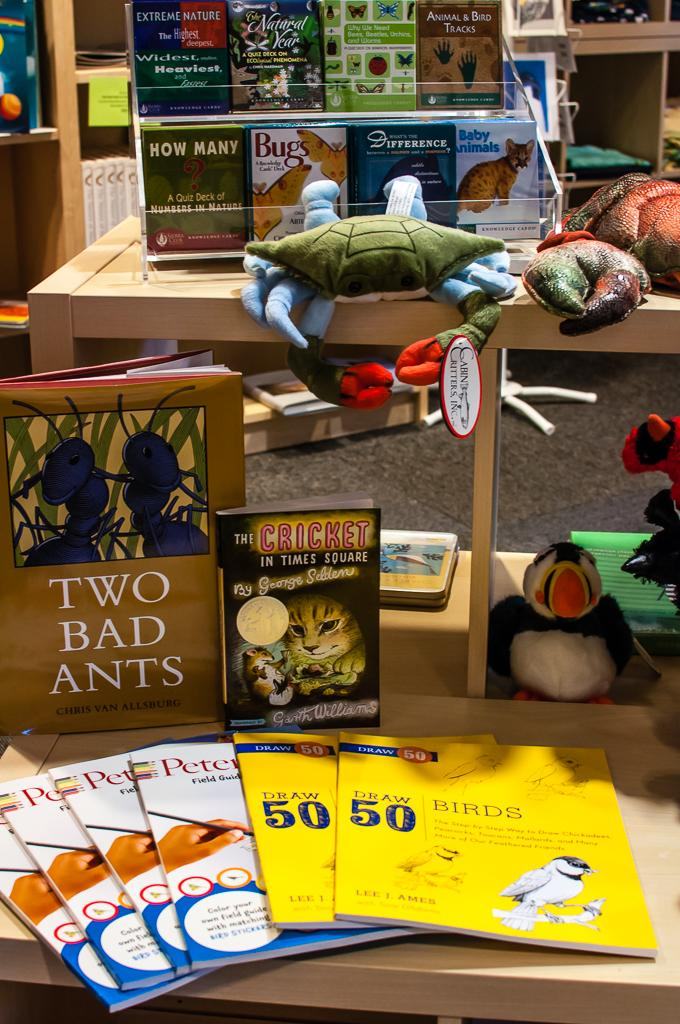<image>
Share a concise interpretation of the image provided. Book called the Two Bad Ants on a table next to a book called The Cricket. 